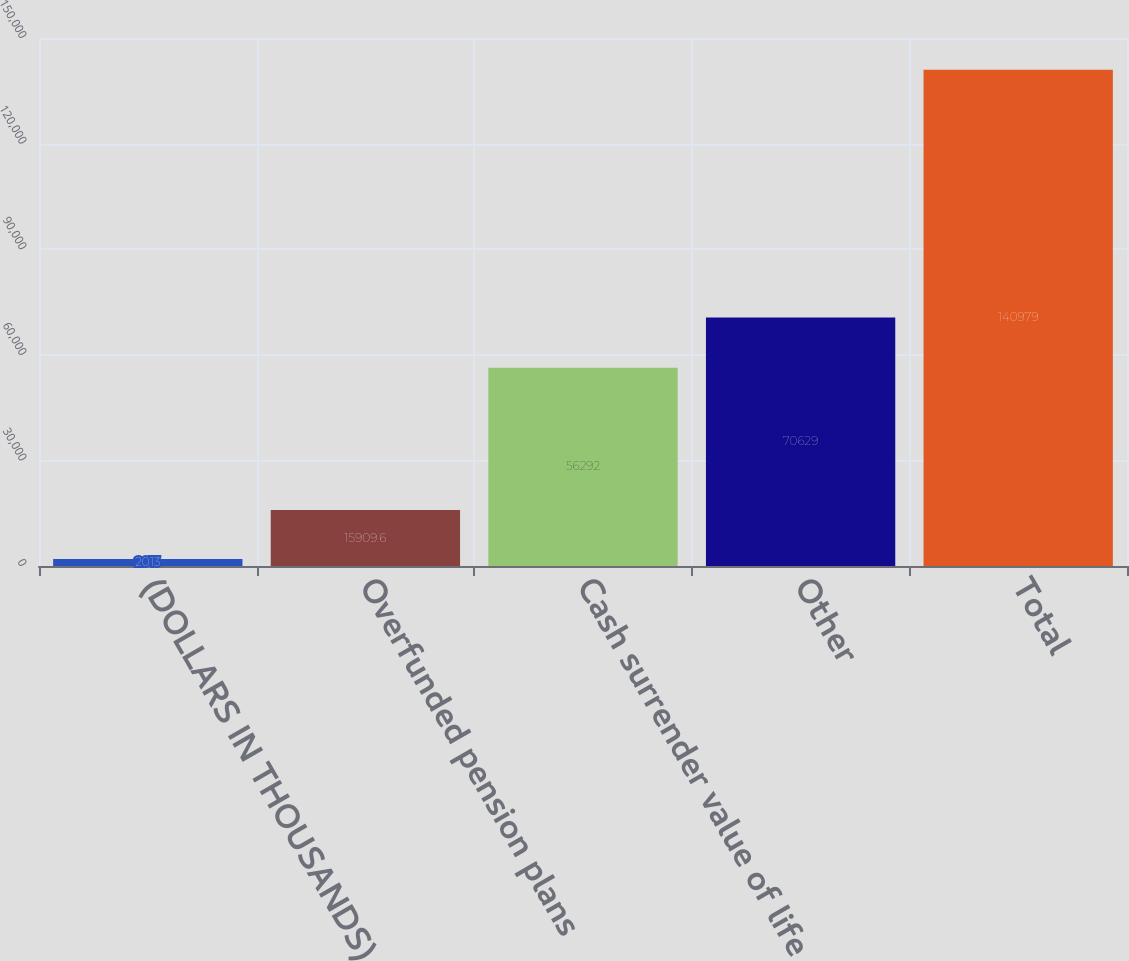Convert chart to OTSL. <chart><loc_0><loc_0><loc_500><loc_500><bar_chart><fcel>(DOLLARS IN THOUSANDS)<fcel>Overfunded pension plans<fcel>Cash surrender value of life<fcel>Other<fcel>Total<nl><fcel>2013<fcel>15909.6<fcel>56292<fcel>70629<fcel>140979<nl></chart> 